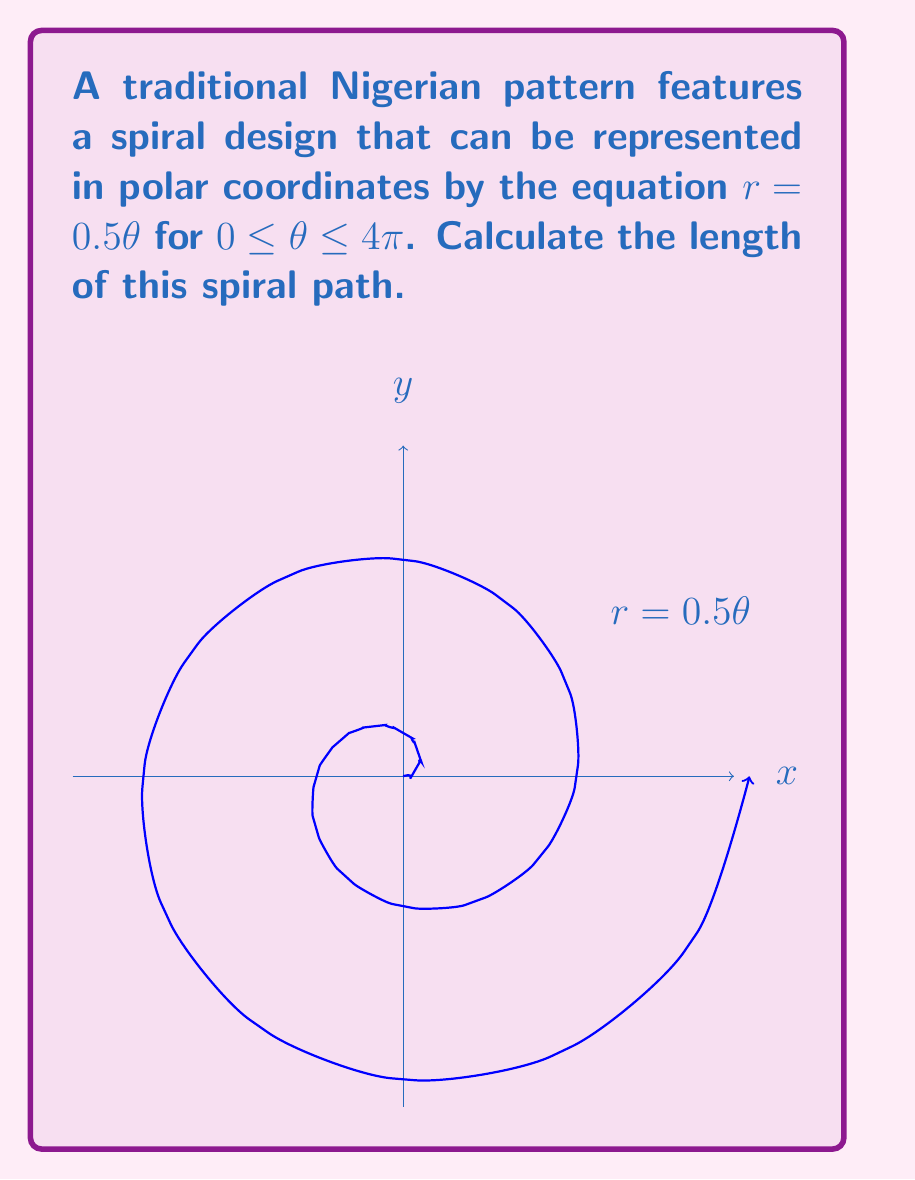Provide a solution to this math problem. To find the length of the spiral path, we need to use the arc length formula for polar curves:

$$L = \int_a^b \sqrt{r^2 + \left(\frac{dr}{d\theta}\right)^2} d\theta$$

1) First, we need to find $\frac{dr}{d\theta}$:
   $r = 0.5\theta$, so $\frac{dr}{d\theta} = 0.5$

2) Now, let's substitute these into the formula:
   $$L = \int_0^{4\pi} \sqrt{(0.5\theta)^2 + (0.5)^2} d\theta$$

3) Simplify inside the square root:
   $$L = \int_0^{4\pi} \sqrt{0.25\theta^2 + 0.25} d\theta$$
   $$L = \int_0^{4\pi} 0.5\sqrt{\theta^2 + 1} d\theta$$

4) This integral can be solved using the substitution $u = \theta^2 + 1$:
   $$L = 0.5 \left[\frac{1}{2}\theta\sqrt{\theta^2+1} + \frac{1}{2}\ln|\theta + \sqrt{\theta^2+1}|\right]_0^{4\pi}$$

5) Evaluate the integral:
   $$L = 0.25\left[4\pi\sqrt{16\pi^2+1} + \ln|4\pi + \sqrt{16\pi^2+1}| - (0 + \ln|1|)\right]$$

6) Simplify:
   $$L \approx 0.25(50.2655 + 3.8198) \approx 13.5213$$
Answer: $13.5213$ units 